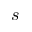Convert formula to latex. <formula><loc_0><loc_0><loc_500><loc_500>s</formula> 